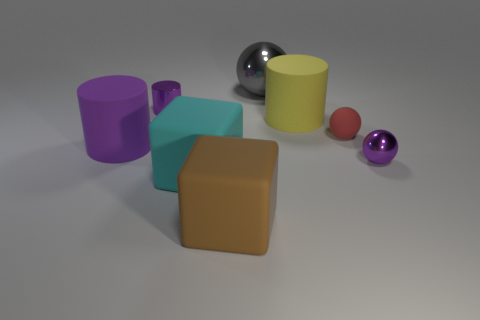Subtract all tiny shiny balls. How many balls are left? 2 Add 2 green shiny cylinders. How many objects exist? 10 Subtract all purple cubes. How many purple cylinders are left? 2 Subtract 1 balls. How many balls are left? 2 Subtract all cyan cubes. How many cubes are left? 1 Subtract all cylinders. How many objects are left? 5 Subtract all yellow cylinders. Subtract all purple balls. How many cylinders are left? 2 Subtract all purple rubber cylinders. Subtract all big matte cylinders. How many objects are left? 5 Add 7 yellow matte things. How many yellow matte things are left? 8 Add 5 tiny cylinders. How many tiny cylinders exist? 6 